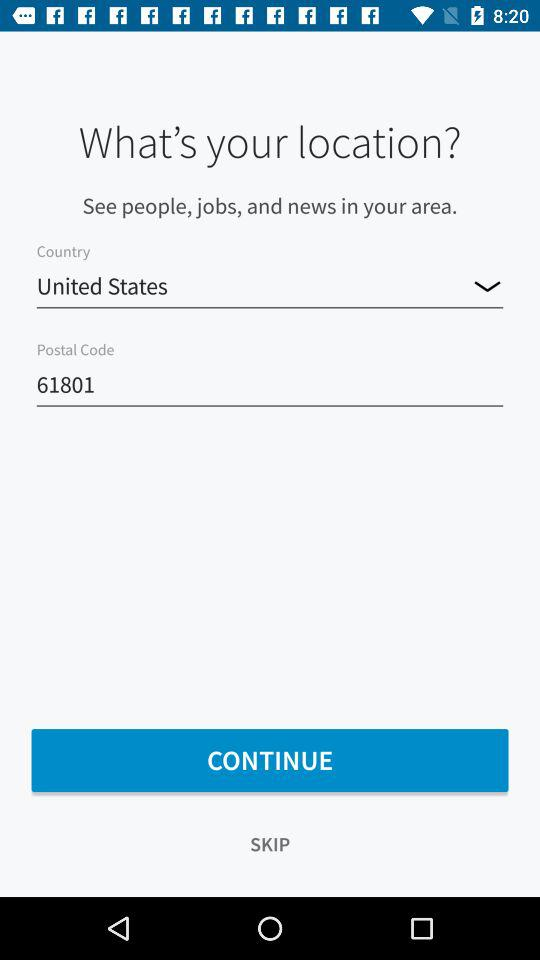Which country is selected? The selected country is the United States. 